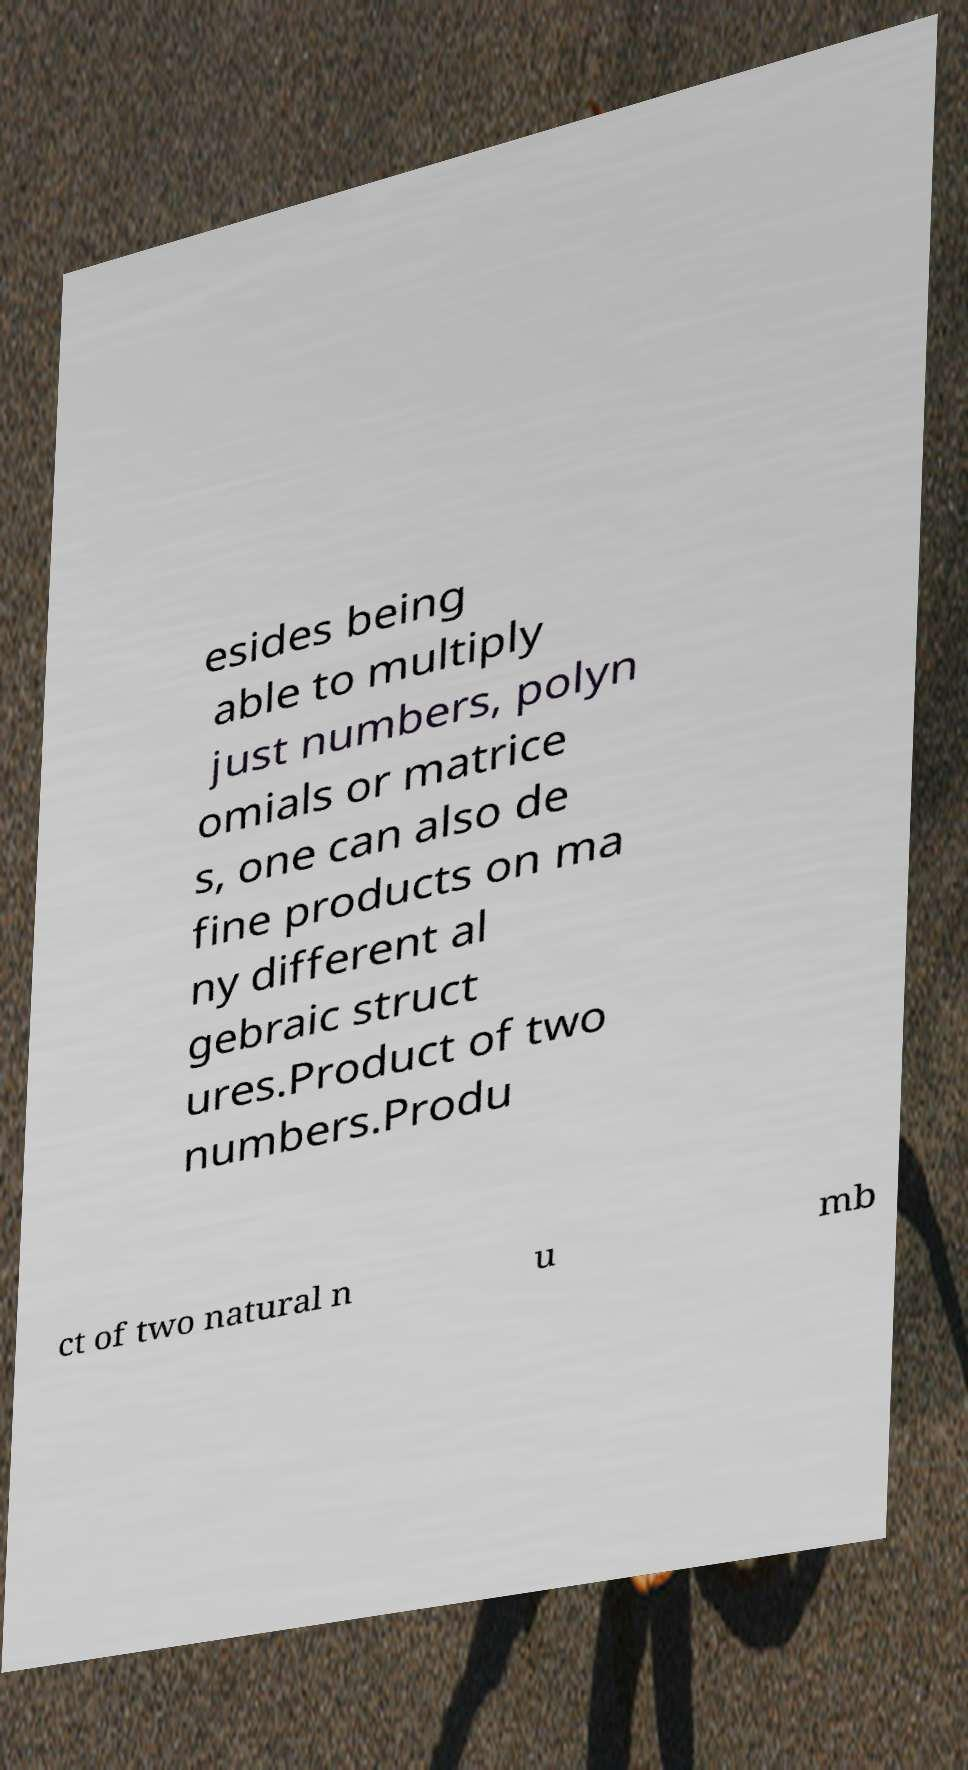For documentation purposes, I need the text within this image transcribed. Could you provide that? esides being able to multiply just numbers, polyn omials or matrice s, one can also de fine products on ma ny different al gebraic struct ures.Product of two numbers.Produ ct of two natural n u mb 